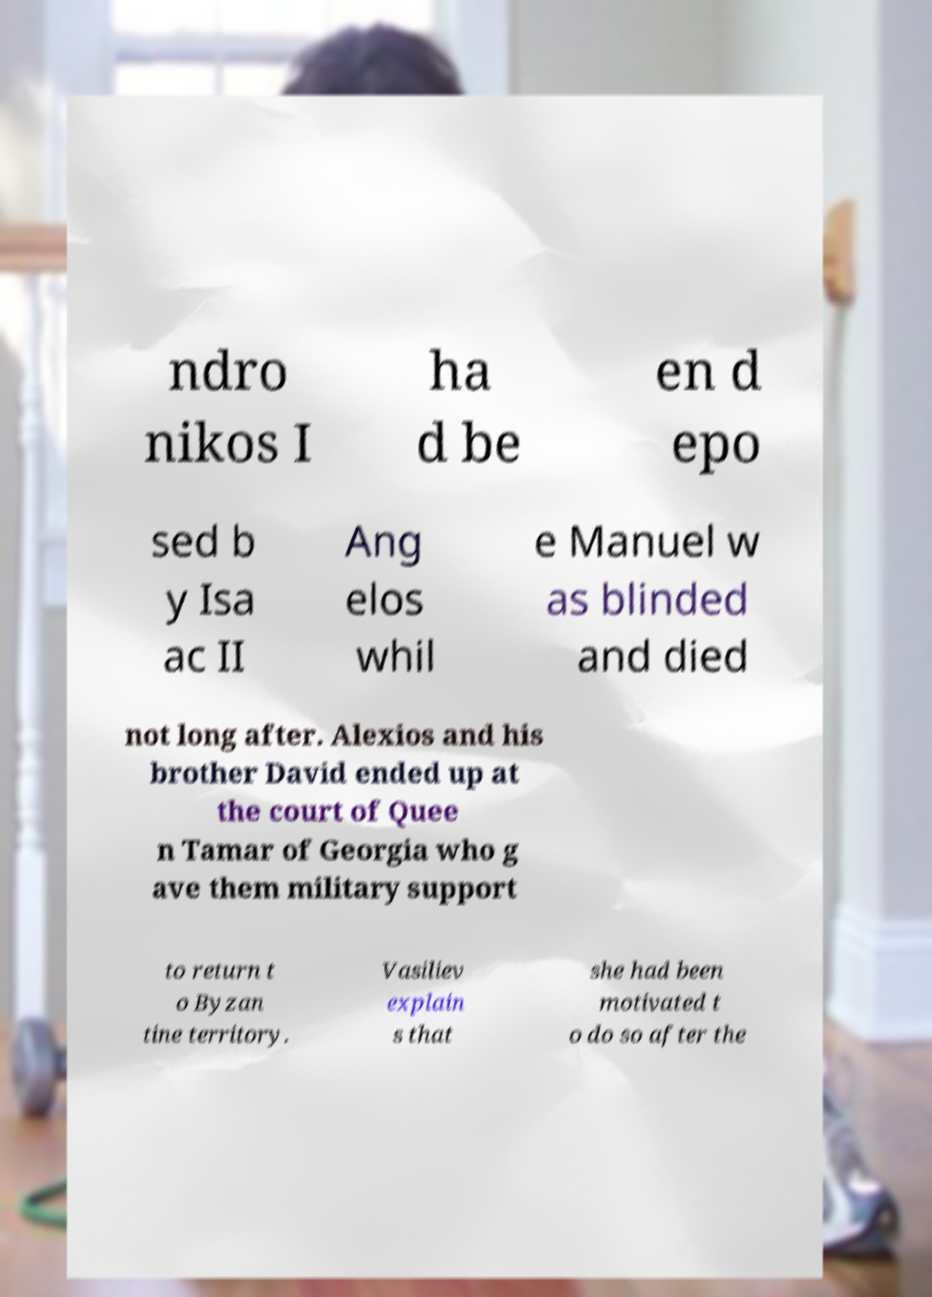What messages or text are displayed in this image? I need them in a readable, typed format. ndro nikos I ha d be en d epo sed b y Isa ac II Ang elos whil e Manuel w as blinded and died not long after. Alexios and his brother David ended up at the court of Quee n Tamar of Georgia who g ave them military support to return t o Byzan tine territory. Vasiliev explain s that she had been motivated t o do so after the 